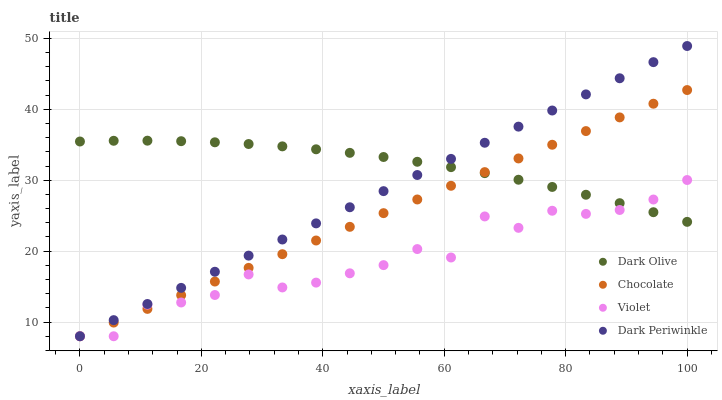Does Violet have the minimum area under the curve?
Answer yes or no. Yes. Does Dark Olive have the maximum area under the curve?
Answer yes or no. Yes. Does Dark Periwinkle have the minimum area under the curve?
Answer yes or no. No. Does Dark Periwinkle have the maximum area under the curve?
Answer yes or no. No. Is Chocolate the smoothest?
Answer yes or no. Yes. Is Violet the roughest?
Answer yes or no. Yes. Is Dark Olive the smoothest?
Answer yes or no. No. Is Dark Olive the roughest?
Answer yes or no. No. Does Violet have the lowest value?
Answer yes or no. Yes. Does Dark Olive have the lowest value?
Answer yes or no. No. Does Dark Periwinkle have the highest value?
Answer yes or no. Yes. Does Dark Olive have the highest value?
Answer yes or no. No. Does Chocolate intersect Dark Periwinkle?
Answer yes or no. Yes. Is Chocolate less than Dark Periwinkle?
Answer yes or no. No. Is Chocolate greater than Dark Periwinkle?
Answer yes or no. No. 